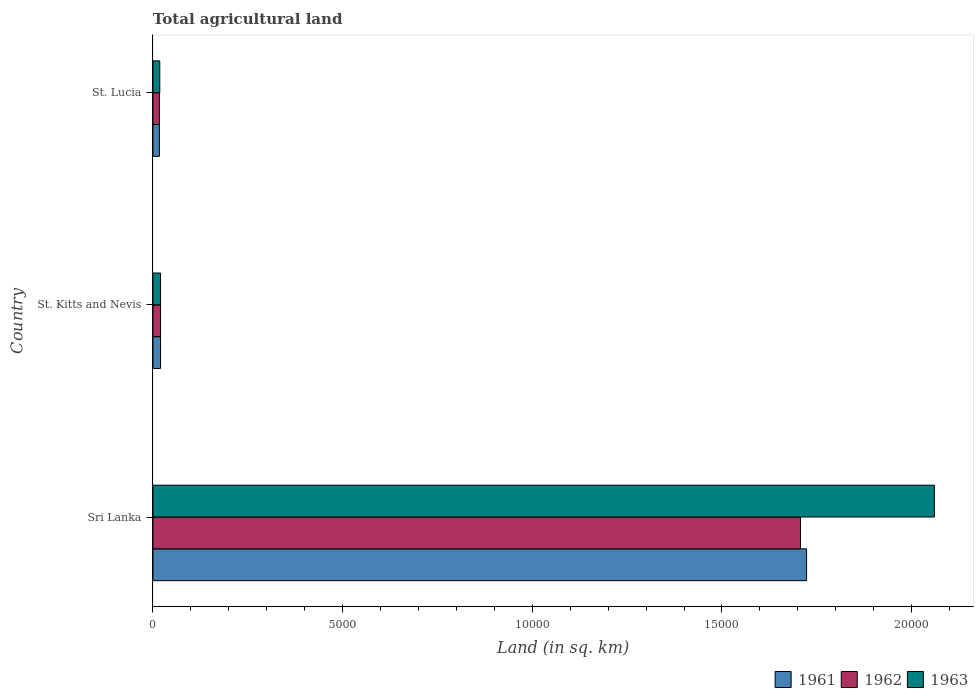How many different coloured bars are there?
Offer a very short reply. 3. How many groups of bars are there?
Offer a very short reply. 3. What is the label of the 2nd group of bars from the top?
Your response must be concise. St. Kitts and Nevis. What is the total agricultural land in 1962 in Sri Lanka?
Provide a short and direct response. 1.71e+04. Across all countries, what is the maximum total agricultural land in 1962?
Ensure brevity in your answer.  1.71e+04. Across all countries, what is the minimum total agricultural land in 1963?
Make the answer very short. 180. In which country was the total agricultural land in 1963 maximum?
Keep it short and to the point. Sri Lanka. In which country was the total agricultural land in 1961 minimum?
Provide a succinct answer. St. Lucia. What is the total total agricultural land in 1961 in the graph?
Keep it short and to the point. 1.76e+04. What is the difference between the total agricultural land in 1962 in Sri Lanka and that in St. Lucia?
Ensure brevity in your answer.  1.69e+04. What is the average total agricultural land in 1963 per country?
Give a very brief answer. 6993.33. In how many countries, is the total agricultural land in 1963 greater than 20000 sq.km?
Provide a succinct answer. 1. What is the ratio of the total agricultural land in 1961 in Sri Lanka to that in St. Lucia?
Offer a very short reply. 101.35. What is the difference between the highest and the second highest total agricultural land in 1961?
Make the answer very short. 1.70e+04. What is the difference between the highest and the lowest total agricultural land in 1961?
Provide a short and direct response. 1.71e+04. Is the sum of the total agricultural land in 1963 in Sri Lanka and St. Kitts and Nevis greater than the maximum total agricultural land in 1961 across all countries?
Offer a very short reply. Yes. How many bars are there?
Offer a terse response. 9. Are all the bars in the graph horizontal?
Your answer should be compact. Yes. What is the difference between two consecutive major ticks on the X-axis?
Your response must be concise. 5000. Are the values on the major ticks of X-axis written in scientific E-notation?
Your answer should be very brief. No. Does the graph contain grids?
Your response must be concise. No. Where does the legend appear in the graph?
Provide a short and direct response. Bottom right. How many legend labels are there?
Keep it short and to the point. 3. How are the legend labels stacked?
Offer a terse response. Horizontal. What is the title of the graph?
Offer a terse response. Total agricultural land. What is the label or title of the X-axis?
Provide a short and direct response. Land (in sq. km). What is the label or title of the Y-axis?
Provide a short and direct response. Country. What is the Land (in sq. km) in 1961 in Sri Lanka?
Provide a short and direct response. 1.72e+04. What is the Land (in sq. km) in 1962 in Sri Lanka?
Your answer should be very brief. 1.71e+04. What is the Land (in sq. km) of 1963 in Sri Lanka?
Your answer should be compact. 2.06e+04. What is the Land (in sq. km) of 1961 in St. Kitts and Nevis?
Keep it short and to the point. 200. What is the Land (in sq. km) in 1963 in St. Kitts and Nevis?
Your response must be concise. 200. What is the Land (in sq. km) of 1961 in St. Lucia?
Your answer should be compact. 170. What is the Land (in sq. km) of 1962 in St. Lucia?
Give a very brief answer. 170. What is the Land (in sq. km) of 1963 in St. Lucia?
Keep it short and to the point. 180. Across all countries, what is the maximum Land (in sq. km) in 1961?
Your answer should be compact. 1.72e+04. Across all countries, what is the maximum Land (in sq. km) of 1962?
Offer a very short reply. 1.71e+04. Across all countries, what is the maximum Land (in sq. km) of 1963?
Provide a short and direct response. 2.06e+04. Across all countries, what is the minimum Land (in sq. km) of 1961?
Provide a succinct answer. 170. Across all countries, what is the minimum Land (in sq. km) in 1962?
Provide a succinct answer. 170. Across all countries, what is the minimum Land (in sq. km) in 1963?
Your answer should be very brief. 180. What is the total Land (in sq. km) in 1961 in the graph?
Ensure brevity in your answer.  1.76e+04. What is the total Land (in sq. km) of 1962 in the graph?
Provide a short and direct response. 1.74e+04. What is the total Land (in sq. km) of 1963 in the graph?
Your answer should be compact. 2.10e+04. What is the difference between the Land (in sq. km) in 1961 in Sri Lanka and that in St. Kitts and Nevis?
Your answer should be very brief. 1.70e+04. What is the difference between the Land (in sq. km) of 1962 in Sri Lanka and that in St. Kitts and Nevis?
Your answer should be very brief. 1.69e+04. What is the difference between the Land (in sq. km) in 1963 in Sri Lanka and that in St. Kitts and Nevis?
Give a very brief answer. 2.04e+04. What is the difference between the Land (in sq. km) in 1961 in Sri Lanka and that in St. Lucia?
Give a very brief answer. 1.71e+04. What is the difference between the Land (in sq. km) of 1962 in Sri Lanka and that in St. Lucia?
Give a very brief answer. 1.69e+04. What is the difference between the Land (in sq. km) in 1963 in Sri Lanka and that in St. Lucia?
Your answer should be very brief. 2.04e+04. What is the difference between the Land (in sq. km) of 1963 in St. Kitts and Nevis and that in St. Lucia?
Offer a terse response. 20. What is the difference between the Land (in sq. km) of 1961 in Sri Lanka and the Land (in sq. km) of 1962 in St. Kitts and Nevis?
Give a very brief answer. 1.70e+04. What is the difference between the Land (in sq. km) of 1961 in Sri Lanka and the Land (in sq. km) of 1963 in St. Kitts and Nevis?
Give a very brief answer. 1.70e+04. What is the difference between the Land (in sq. km) of 1962 in Sri Lanka and the Land (in sq. km) of 1963 in St. Kitts and Nevis?
Provide a succinct answer. 1.69e+04. What is the difference between the Land (in sq. km) of 1961 in Sri Lanka and the Land (in sq. km) of 1962 in St. Lucia?
Offer a terse response. 1.71e+04. What is the difference between the Land (in sq. km) in 1961 in Sri Lanka and the Land (in sq. km) in 1963 in St. Lucia?
Keep it short and to the point. 1.70e+04. What is the difference between the Land (in sq. km) in 1962 in Sri Lanka and the Land (in sq. km) in 1963 in St. Lucia?
Ensure brevity in your answer.  1.69e+04. What is the difference between the Land (in sq. km) in 1961 in St. Kitts and Nevis and the Land (in sq. km) in 1962 in St. Lucia?
Your answer should be very brief. 30. What is the average Land (in sq. km) in 1961 per country?
Your response must be concise. 5866.67. What is the average Land (in sq. km) in 1962 per country?
Make the answer very short. 5813.33. What is the average Land (in sq. km) in 1963 per country?
Your answer should be compact. 6993.33. What is the difference between the Land (in sq. km) of 1961 and Land (in sq. km) of 1962 in Sri Lanka?
Keep it short and to the point. 160. What is the difference between the Land (in sq. km) in 1961 and Land (in sq. km) in 1963 in Sri Lanka?
Your answer should be compact. -3370. What is the difference between the Land (in sq. km) of 1962 and Land (in sq. km) of 1963 in Sri Lanka?
Your answer should be compact. -3530. What is the difference between the Land (in sq. km) of 1961 and Land (in sq. km) of 1963 in St. Kitts and Nevis?
Keep it short and to the point. 0. What is the difference between the Land (in sq. km) in 1961 and Land (in sq. km) in 1962 in St. Lucia?
Your answer should be very brief. 0. What is the difference between the Land (in sq. km) in 1961 and Land (in sq. km) in 1963 in St. Lucia?
Keep it short and to the point. -10. What is the difference between the Land (in sq. km) in 1962 and Land (in sq. km) in 1963 in St. Lucia?
Ensure brevity in your answer.  -10. What is the ratio of the Land (in sq. km) in 1961 in Sri Lanka to that in St. Kitts and Nevis?
Your answer should be compact. 86.15. What is the ratio of the Land (in sq. km) of 1962 in Sri Lanka to that in St. Kitts and Nevis?
Offer a very short reply. 85.35. What is the ratio of the Land (in sq. km) of 1963 in Sri Lanka to that in St. Kitts and Nevis?
Provide a succinct answer. 103. What is the ratio of the Land (in sq. km) of 1961 in Sri Lanka to that in St. Lucia?
Make the answer very short. 101.35. What is the ratio of the Land (in sq. km) in 1962 in Sri Lanka to that in St. Lucia?
Your answer should be very brief. 100.41. What is the ratio of the Land (in sq. km) in 1963 in Sri Lanka to that in St. Lucia?
Your answer should be very brief. 114.44. What is the ratio of the Land (in sq. km) of 1961 in St. Kitts and Nevis to that in St. Lucia?
Keep it short and to the point. 1.18. What is the ratio of the Land (in sq. km) in 1962 in St. Kitts and Nevis to that in St. Lucia?
Offer a very short reply. 1.18. What is the ratio of the Land (in sq. km) in 1963 in St. Kitts and Nevis to that in St. Lucia?
Keep it short and to the point. 1.11. What is the difference between the highest and the second highest Land (in sq. km) in 1961?
Ensure brevity in your answer.  1.70e+04. What is the difference between the highest and the second highest Land (in sq. km) of 1962?
Provide a short and direct response. 1.69e+04. What is the difference between the highest and the second highest Land (in sq. km) of 1963?
Your answer should be compact. 2.04e+04. What is the difference between the highest and the lowest Land (in sq. km) of 1961?
Your response must be concise. 1.71e+04. What is the difference between the highest and the lowest Land (in sq. km) in 1962?
Your answer should be compact. 1.69e+04. What is the difference between the highest and the lowest Land (in sq. km) of 1963?
Ensure brevity in your answer.  2.04e+04. 